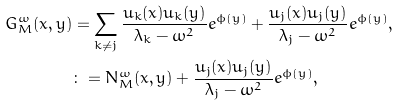<formula> <loc_0><loc_0><loc_500><loc_500>G ^ { \omega } _ { M } ( x , y ) & = \sum _ { k \neq j } \frac { u _ { k } ( x ) u _ { k } ( y ) } { \lambda _ { k } - \omega ^ { 2 } } e ^ { \phi ( y ) } + \frac { u _ { j } ( x ) u _ { j } ( y ) } { \lambda _ { j } - \omega ^ { 2 } } e ^ { \phi ( y ) } , \\ & \colon = N ^ { \omega } _ { M } ( x , y ) + \frac { u _ { j } ( x ) u _ { j } ( y ) } { \lambda _ { j } - \omega ^ { 2 } } e ^ { \phi ( y ) } ,</formula> 